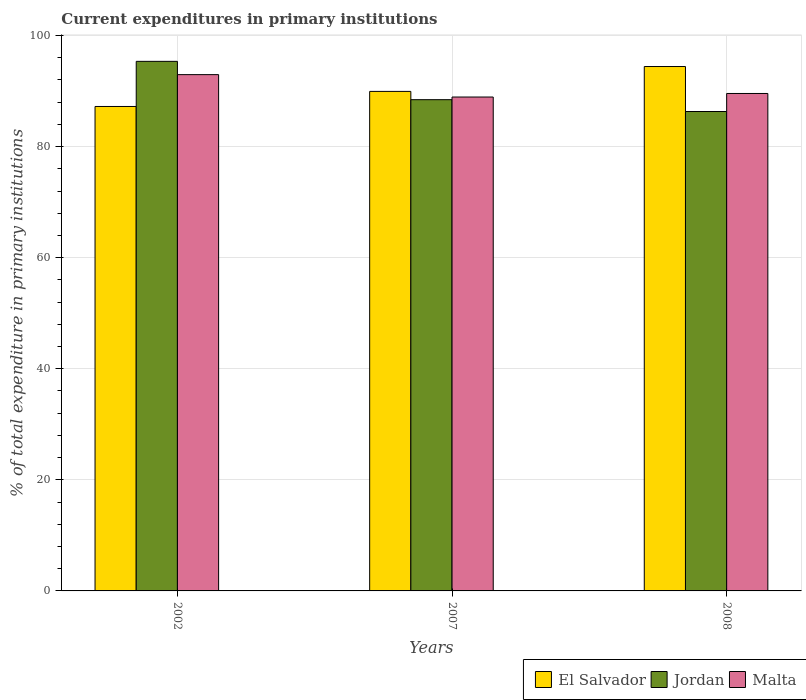How many different coloured bars are there?
Offer a very short reply. 3. Are the number of bars on each tick of the X-axis equal?
Your answer should be very brief. Yes. How many bars are there on the 3rd tick from the left?
Give a very brief answer. 3. What is the current expenditures in primary institutions in Jordan in 2007?
Ensure brevity in your answer.  88.45. Across all years, what is the maximum current expenditures in primary institutions in Malta?
Provide a succinct answer. 92.96. Across all years, what is the minimum current expenditures in primary institutions in El Salvador?
Provide a short and direct response. 87.23. In which year was the current expenditures in primary institutions in El Salvador minimum?
Your response must be concise. 2002. What is the total current expenditures in primary institutions in El Salvador in the graph?
Offer a terse response. 271.6. What is the difference between the current expenditures in primary institutions in Jordan in 2007 and that in 2008?
Offer a very short reply. 2.13. What is the difference between the current expenditures in primary institutions in Malta in 2008 and the current expenditures in primary institutions in El Salvador in 2002?
Give a very brief answer. 2.34. What is the average current expenditures in primary institutions in Malta per year?
Your response must be concise. 90.49. In the year 2007, what is the difference between the current expenditures in primary institutions in Jordan and current expenditures in primary institutions in Malta?
Provide a succinct answer. -0.48. In how many years, is the current expenditures in primary institutions in El Salvador greater than 44 %?
Make the answer very short. 3. What is the ratio of the current expenditures in primary institutions in Jordan in 2002 to that in 2008?
Ensure brevity in your answer.  1.1. Is the current expenditures in primary institutions in Jordan in 2002 less than that in 2007?
Your answer should be compact. No. What is the difference between the highest and the second highest current expenditures in primary institutions in El Salvador?
Your answer should be very brief. 4.48. What is the difference between the highest and the lowest current expenditures in primary institutions in El Salvador?
Offer a very short reply. 7.19. Is the sum of the current expenditures in primary institutions in Malta in 2007 and 2008 greater than the maximum current expenditures in primary institutions in El Salvador across all years?
Offer a terse response. Yes. What does the 3rd bar from the left in 2007 represents?
Your answer should be very brief. Malta. What does the 3rd bar from the right in 2002 represents?
Your response must be concise. El Salvador. How many bars are there?
Offer a terse response. 9. Are all the bars in the graph horizontal?
Provide a succinct answer. No. Does the graph contain any zero values?
Give a very brief answer. No. Does the graph contain grids?
Your answer should be very brief. Yes. How are the legend labels stacked?
Your response must be concise. Horizontal. What is the title of the graph?
Your response must be concise. Current expenditures in primary institutions. Does "Egypt, Arab Rep." appear as one of the legend labels in the graph?
Make the answer very short. No. What is the label or title of the Y-axis?
Provide a succinct answer. % of total expenditure in primary institutions. What is the % of total expenditure in primary institutions of El Salvador in 2002?
Ensure brevity in your answer.  87.23. What is the % of total expenditure in primary institutions in Jordan in 2002?
Make the answer very short. 95.35. What is the % of total expenditure in primary institutions in Malta in 2002?
Keep it short and to the point. 92.96. What is the % of total expenditure in primary institutions of El Salvador in 2007?
Give a very brief answer. 89.95. What is the % of total expenditure in primary institutions in Jordan in 2007?
Offer a very short reply. 88.45. What is the % of total expenditure in primary institutions of Malta in 2007?
Provide a short and direct response. 88.93. What is the % of total expenditure in primary institutions of El Salvador in 2008?
Your answer should be very brief. 94.42. What is the % of total expenditure in primary institutions in Jordan in 2008?
Offer a terse response. 86.32. What is the % of total expenditure in primary institutions of Malta in 2008?
Ensure brevity in your answer.  89.57. Across all years, what is the maximum % of total expenditure in primary institutions of El Salvador?
Provide a succinct answer. 94.42. Across all years, what is the maximum % of total expenditure in primary institutions of Jordan?
Your answer should be very brief. 95.35. Across all years, what is the maximum % of total expenditure in primary institutions in Malta?
Give a very brief answer. 92.96. Across all years, what is the minimum % of total expenditure in primary institutions in El Salvador?
Offer a terse response. 87.23. Across all years, what is the minimum % of total expenditure in primary institutions in Jordan?
Give a very brief answer. 86.32. Across all years, what is the minimum % of total expenditure in primary institutions of Malta?
Make the answer very short. 88.93. What is the total % of total expenditure in primary institutions of El Salvador in the graph?
Make the answer very short. 271.6. What is the total % of total expenditure in primary institutions in Jordan in the graph?
Keep it short and to the point. 270.13. What is the total % of total expenditure in primary institutions in Malta in the graph?
Your answer should be compact. 271.47. What is the difference between the % of total expenditure in primary institutions in El Salvador in 2002 and that in 2007?
Provide a succinct answer. -2.72. What is the difference between the % of total expenditure in primary institutions in Jordan in 2002 and that in 2007?
Provide a short and direct response. 6.9. What is the difference between the % of total expenditure in primary institutions of Malta in 2002 and that in 2007?
Your response must be concise. 4.03. What is the difference between the % of total expenditure in primary institutions in El Salvador in 2002 and that in 2008?
Your answer should be very brief. -7.19. What is the difference between the % of total expenditure in primary institutions in Jordan in 2002 and that in 2008?
Offer a very short reply. 9.03. What is the difference between the % of total expenditure in primary institutions of Malta in 2002 and that in 2008?
Give a very brief answer. 3.39. What is the difference between the % of total expenditure in primary institutions in El Salvador in 2007 and that in 2008?
Give a very brief answer. -4.48. What is the difference between the % of total expenditure in primary institutions of Jordan in 2007 and that in 2008?
Give a very brief answer. 2.13. What is the difference between the % of total expenditure in primary institutions in Malta in 2007 and that in 2008?
Provide a short and direct response. -0.64. What is the difference between the % of total expenditure in primary institutions in El Salvador in 2002 and the % of total expenditure in primary institutions in Jordan in 2007?
Provide a succinct answer. -1.22. What is the difference between the % of total expenditure in primary institutions of El Salvador in 2002 and the % of total expenditure in primary institutions of Malta in 2007?
Give a very brief answer. -1.7. What is the difference between the % of total expenditure in primary institutions in Jordan in 2002 and the % of total expenditure in primary institutions in Malta in 2007?
Your answer should be compact. 6.42. What is the difference between the % of total expenditure in primary institutions of El Salvador in 2002 and the % of total expenditure in primary institutions of Jordan in 2008?
Provide a succinct answer. 0.91. What is the difference between the % of total expenditure in primary institutions in El Salvador in 2002 and the % of total expenditure in primary institutions in Malta in 2008?
Ensure brevity in your answer.  -2.34. What is the difference between the % of total expenditure in primary institutions in Jordan in 2002 and the % of total expenditure in primary institutions in Malta in 2008?
Provide a short and direct response. 5.79. What is the difference between the % of total expenditure in primary institutions of El Salvador in 2007 and the % of total expenditure in primary institutions of Jordan in 2008?
Give a very brief answer. 3.62. What is the difference between the % of total expenditure in primary institutions in El Salvador in 2007 and the % of total expenditure in primary institutions in Malta in 2008?
Your answer should be compact. 0.38. What is the difference between the % of total expenditure in primary institutions of Jordan in 2007 and the % of total expenditure in primary institutions of Malta in 2008?
Your answer should be compact. -1.11. What is the average % of total expenditure in primary institutions of El Salvador per year?
Your answer should be compact. 90.53. What is the average % of total expenditure in primary institutions in Jordan per year?
Offer a terse response. 90.04. What is the average % of total expenditure in primary institutions in Malta per year?
Offer a very short reply. 90.49. In the year 2002, what is the difference between the % of total expenditure in primary institutions in El Salvador and % of total expenditure in primary institutions in Jordan?
Your answer should be compact. -8.12. In the year 2002, what is the difference between the % of total expenditure in primary institutions of El Salvador and % of total expenditure in primary institutions of Malta?
Offer a terse response. -5.73. In the year 2002, what is the difference between the % of total expenditure in primary institutions in Jordan and % of total expenditure in primary institutions in Malta?
Provide a short and direct response. 2.39. In the year 2007, what is the difference between the % of total expenditure in primary institutions of El Salvador and % of total expenditure in primary institutions of Jordan?
Offer a terse response. 1.49. In the year 2007, what is the difference between the % of total expenditure in primary institutions of El Salvador and % of total expenditure in primary institutions of Malta?
Make the answer very short. 1.01. In the year 2007, what is the difference between the % of total expenditure in primary institutions in Jordan and % of total expenditure in primary institutions in Malta?
Provide a short and direct response. -0.48. In the year 2008, what is the difference between the % of total expenditure in primary institutions of El Salvador and % of total expenditure in primary institutions of Jordan?
Ensure brevity in your answer.  8.1. In the year 2008, what is the difference between the % of total expenditure in primary institutions in El Salvador and % of total expenditure in primary institutions in Malta?
Your answer should be very brief. 4.86. In the year 2008, what is the difference between the % of total expenditure in primary institutions in Jordan and % of total expenditure in primary institutions in Malta?
Offer a very short reply. -3.25. What is the ratio of the % of total expenditure in primary institutions in El Salvador in 2002 to that in 2007?
Provide a succinct answer. 0.97. What is the ratio of the % of total expenditure in primary institutions in Jordan in 2002 to that in 2007?
Offer a very short reply. 1.08. What is the ratio of the % of total expenditure in primary institutions of Malta in 2002 to that in 2007?
Provide a short and direct response. 1.05. What is the ratio of the % of total expenditure in primary institutions in El Salvador in 2002 to that in 2008?
Offer a very short reply. 0.92. What is the ratio of the % of total expenditure in primary institutions in Jordan in 2002 to that in 2008?
Provide a succinct answer. 1.1. What is the ratio of the % of total expenditure in primary institutions in Malta in 2002 to that in 2008?
Your answer should be compact. 1.04. What is the ratio of the % of total expenditure in primary institutions of El Salvador in 2007 to that in 2008?
Provide a short and direct response. 0.95. What is the ratio of the % of total expenditure in primary institutions in Jordan in 2007 to that in 2008?
Offer a terse response. 1.02. What is the difference between the highest and the second highest % of total expenditure in primary institutions in El Salvador?
Your answer should be very brief. 4.48. What is the difference between the highest and the second highest % of total expenditure in primary institutions of Jordan?
Your answer should be compact. 6.9. What is the difference between the highest and the second highest % of total expenditure in primary institutions in Malta?
Your answer should be compact. 3.39. What is the difference between the highest and the lowest % of total expenditure in primary institutions of El Salvador?
Your answer should be compact. 7.19. What is the difference between the highest and the lowest % of total expenditure in primary institutions of Jordan?
Provide a short and direct response. 9.03. What is the difference between the highest and the lowest % of total expenditure in primary institutions of Malta?
Make the answer very short. 4.03. 